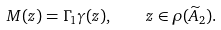<formula> <loc_0><loc_0><loc_500><loc_500>M ( z ) = \Gamma _ { 1 } \gamma ( z ) , \quad z \in \rho ( \widetilde { A } _ { 2 } ) .</formula> 